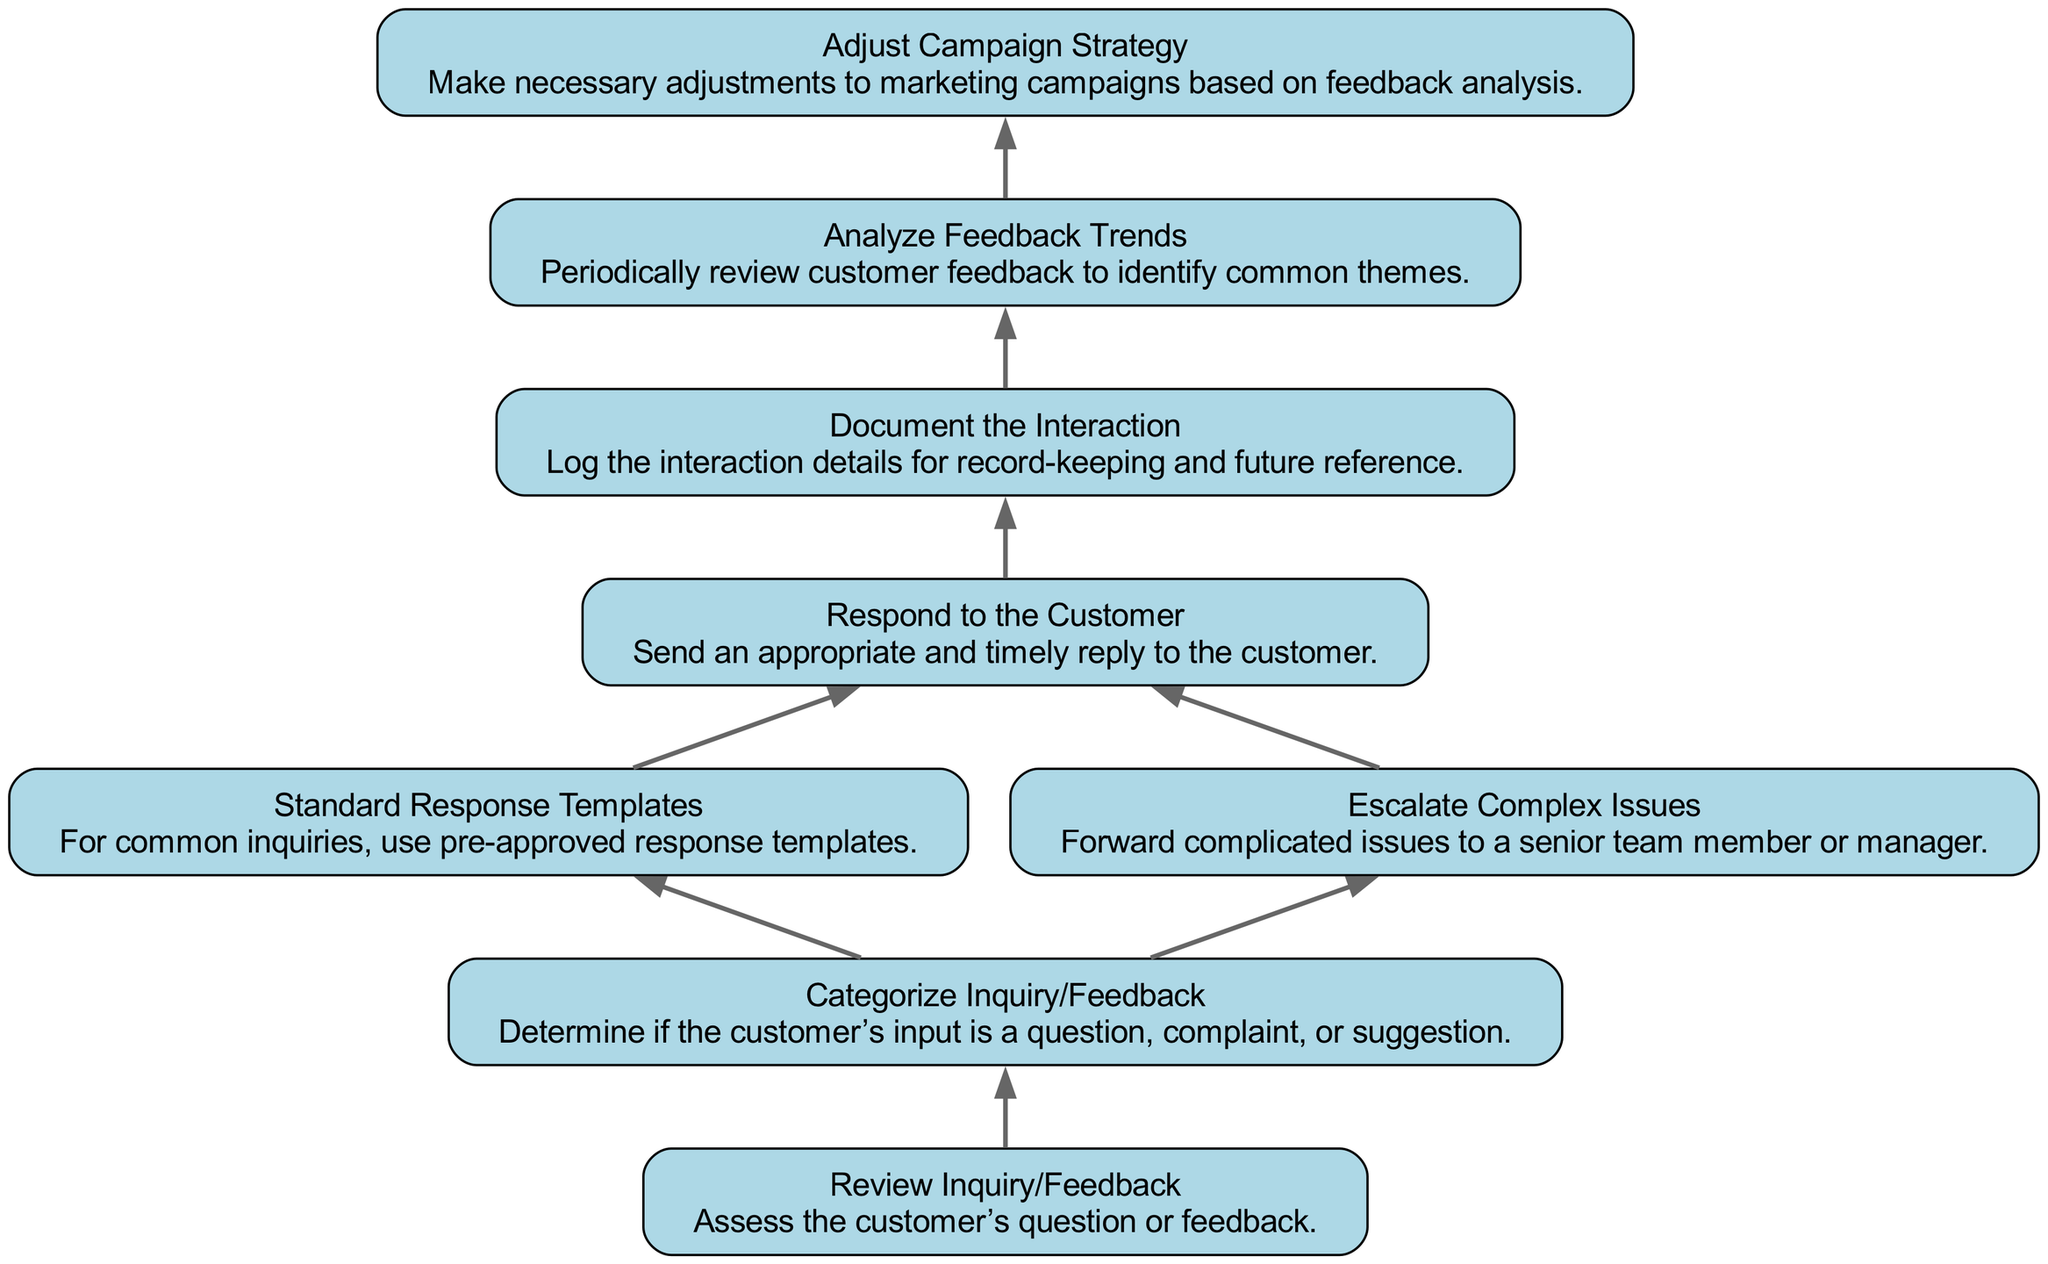What is the first step in handling customer inquiries? The first step in the flow chart is "Review Inquiry/Feedback," which means assessing the customer’s question or feedback.
Answer: Review Inquiry/Feedback How many nodes are present in the flow chart? There are 8 nodes in the flow chart, which represent different steps in handling customer inquiries and feedback.
Answer: 8 What action follows after responding to the customer? After responding to the customer, the next action is to "Document the Interaction," which involves logging the details for record-keeping.
Answer: Document the Interaction Which nodes lead to "Adjust Campaign Strategy"? The node that directly leads to "Adjust Campaign Strategy" is "Analyze Feedback Trends," reflecting that this step is based on feedback analysis.
Answer: Analyze Feedback Trends If a complex issue arises, what should be done next? The flow chart indicates that a complex issue should be escalated to a senior team member or manager, as stated in the node "Escalate Complex Issues."
Answer: Escalate Complex Issues Which node utilizes pre-approved response templates? The node "Standard Response Templates" describes the action of using pre-approved response templates for common inquiries.
Answer: Standard Response Templates What is the last step in the flow chart? The last step in the flow chart is "Adjust Campaign Strategy," which refers to making necessary adjustments based on feedback analysis.
Answer: Adjust Campaign Strategy What is the relationship between "Categorize Inquiry/Feedback" and the subsequent actions? "Categorize Inquiry/Feedback" serves as a decision point where actions like responding to the customer or escalating complex issues can be determined based on the input type.
Answer: Decision point 